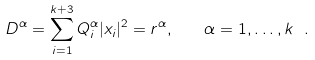Convert formula to latex. <formula><loc_0><loc_0><loc_500><loc_500>D ^ { \alpha } = \sum _ { i = 1 } ^ { k + 3 } Q _ { i } ^ { \alpha } | x _ { i } | ^ { 2 } = r ^ { \alpha } , \quad \alpha = 1 , \dots , k \ .</formula> 